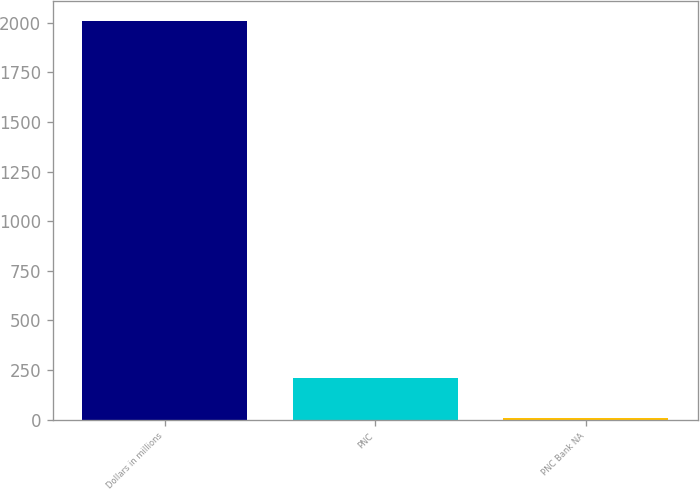<chart> <loc_0><loc_0><loc_500><loc_500><bar_chart><fcel>Dollars in millions<fcel>PNC<fcel>PNC Bank NA<nl><fcel>2008<fcel>207.19<fcel>7.1<nl></chart> 